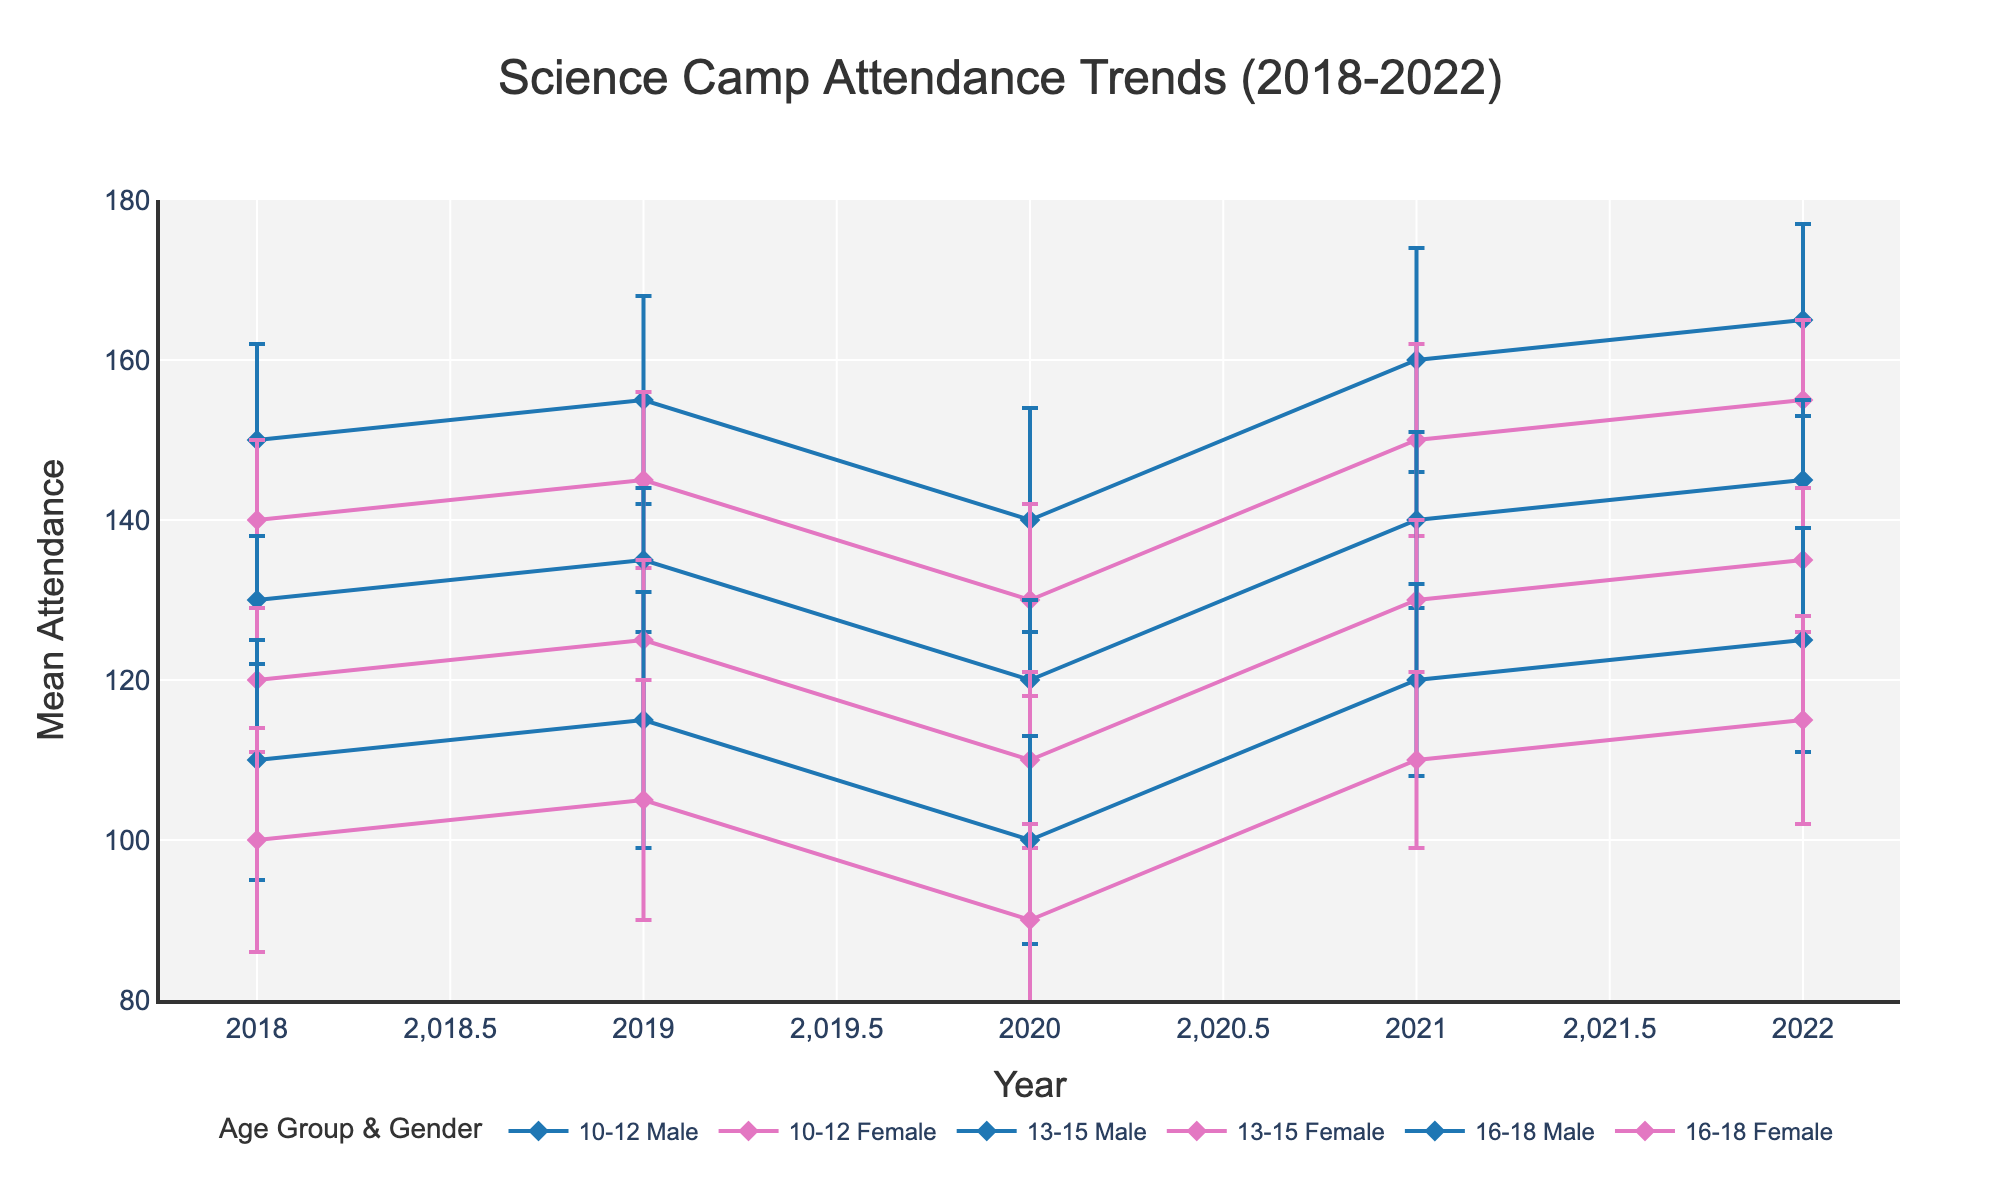What is the title of the plot? The title of the plot is displayed at the top and reads "Science Camp Attendance Trends (2018-2022)."
Answer: Science Camp Attendance Trends (2018-2022) Which age group and gender had the highest mean attendance in 2021? In 2021, the age group 10-12 Male has the highest mean attendance. This can be checked by looking at the y-values and labels for 2021 along the plot.
Answer: 10-12 Male Did the attendance for 13-15 Female increase or decrease from 2020 to 2021? To check this, look for the data points and lines associated with 13-15 Female in 2020 and 2021. In 2020, the attendance is around 110, and in 2021, it increases to 130. So, the attendance increased.
Answer: Increased Which year shows the lowest attendance for age group 16-18 Female? By tracking the line for 16-18 Female across all years, the lowest point is visible in 2020 with an attendance of about 90.
Answer: 2020 Compare the mean attendance of the 10-12 Male group in 2018 and 2022. Which year had higher attendance, and by how much? In 2018, the mean attendance for 10-12 Male was 150. In 2022, it was 165. The difference is 165 - 150 = 15 higher in 2022.
Answer: 2022 by 15 What is the average attendance over the five years for the 16-18 Male group? To determine the average, sum the attendances from 2018 to 2022: 110, 115, 100, 120, 125. Then divide by 5: (110+115+100+120+125)/5 = 570/5 = 114.
Answer: 114 How does the standard deviation for 13-15 Female in 2019 compare to that in 2021? In 2019, the standard deviation for 13-15 Female is 10, while in 2021 it is slightly lower at 9. Compare these two values directly to notice the decrease.
Answer: Lower in 2021 by 1 Which gender has higher attendance in the age group 10-12 in 2020? By comparing the attendance values in the 10-12 age group for 2020, Males had 140 while Females had 130. Thus, Males had higher attendance.
Answer: Male How do the error bars for 16-18 Female in 2022 compare to those in 2020? The error bars represent the standard deviation. In 2022, the standard deviation is 13, while in 2020 it is 12. The error bars are slightly larger in 2022.
Answer: Larger in 2022 Was there an increasing or decreasing trend in overall attendance for age group 10-12 Female from 2018 to 2022? Observing the trend line for 10-12 Female from 2018 (140) to 2022 (155), the values generally increase, indicating an increasing trend.
Answer: Increasing 